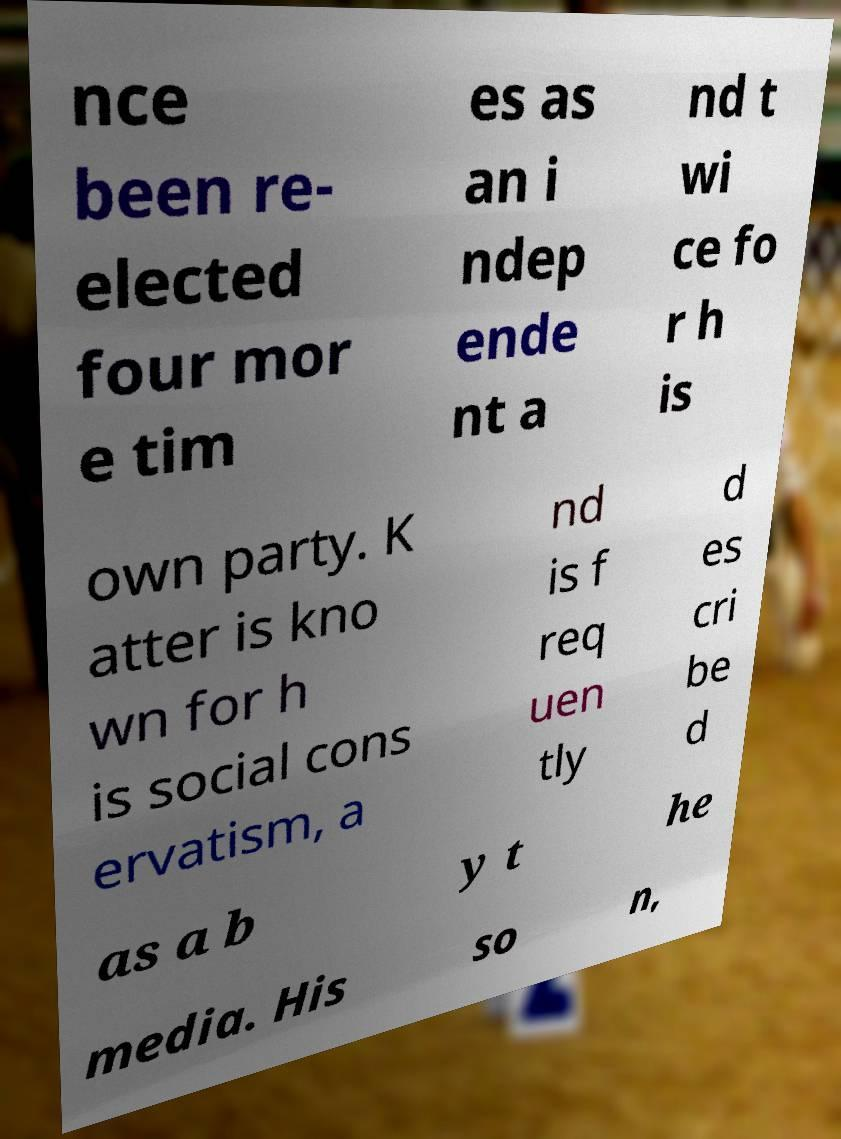Could you assist in decoding the text presented in this image and type it out clearly? nce been re- elected four mor e tim es as an i ndep ende nt a nd t wi ce fo r h is own party. K atter is kno wn for h is social cons ervatism, a nd is f req uen tly d es cri be d as a b y t he media. His so n, 